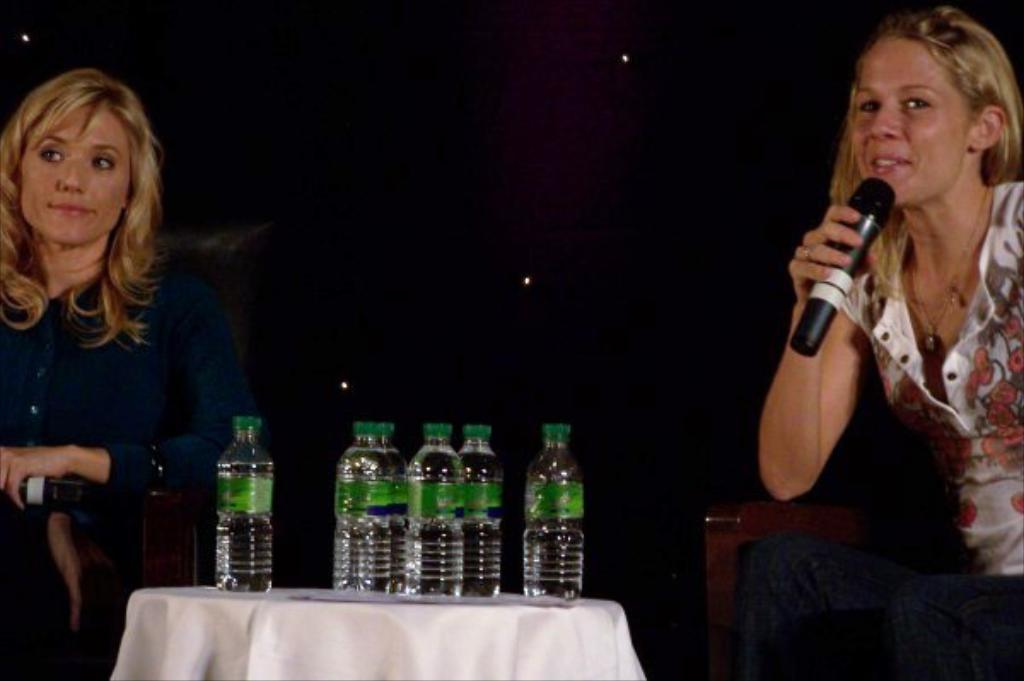How many people are in the image? There are two persons standing in the image. What are the persons holding in their hands? The persons are holding microphones in their hands. What is in front of the persons? There is a table in front of the persons. What can be seen on the table? Water bottles are present on the table. What is the profit generated by the microphones in the image? There is no information about profit in the image, as it only shows two persons holding microphones and a table with water bottles. 